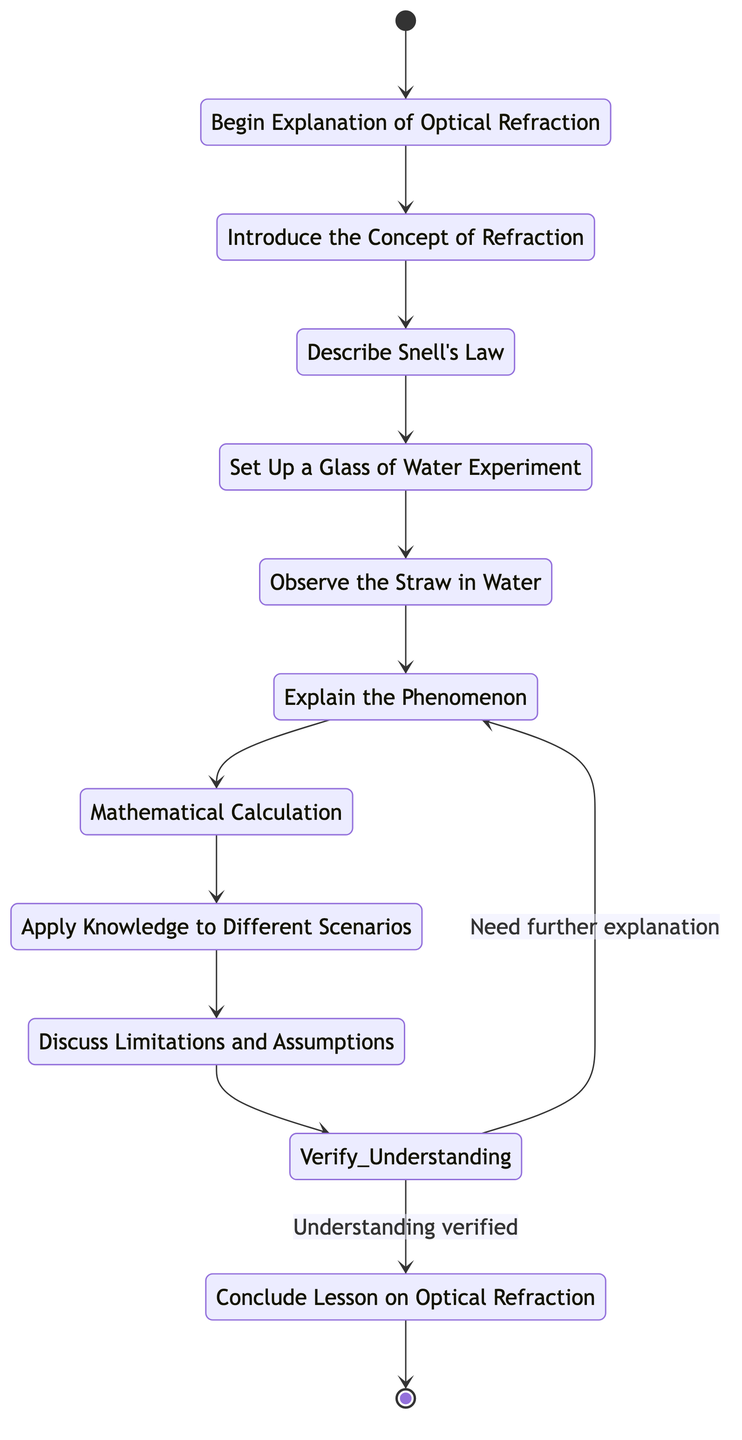What is the starting point of the activity diagram? The starting point is labeled as "Begin Explanation of Optical Refraction," indicating where the explanation process begins. This is the entry point from the initial state, leading to the first activity in the sequence.
Answer: Begin Explanation of Optical Refraction How many activities are listed in the diagram? There are eight activities outlined in the diagram, each of which describes a step in the explanation of optical refraction.
Answer: Eight What activity comes after "Describe Snell's Law"? The diagram shows that after "Describe Snell's Law," the next activity is "Set Up a Glass of Water Experiment." This indicates a direct flow from one task to the next in the instructional sequence.
Answer: Set Up a Glass of Water Experiment What is the decision point in this activity diagram? The decision point, indicated in the diagram, is "Verify Understanding." This represents a moment where the instructor determines whether the students grasp the concepts presented before proceeding.
Answer: Verify Understanding If the understanding is not verified, what happens next? If students do not understand the concepts, the flow goes back to "Explain the Phenomenon," indicating that further clarification and explanation are necessary to ensure comprehension before proceeding to the conclusion.
Answer: Explain the Phenomenon What is the final outcome of the diagram? The end event is labeled "Conclude Lesson on Optical Refraction," summarizing the key points discussed in the lesson and marking the conclusion of the activity flow.
Answer: Conclude Lesson on Optical Refraction Which activity emphasizes a real-world application of the concept? The activity that focuses on applying knowledge to real-world scenarios is "Apply Knowledge to Different Scenarios," encouraging students to think of other examples related to refraction.
Answer: Apply Knowledge to Different Scenarios What does the discussion of "Limitations and Assumptions" entail? The discussion of "Limitations and Assumptions" is an activity that elaborates on the constraints of the experiment and the assumptions made during the calculations regarding optical refraction, fostering critical thinking.
Answer: Discuss Limitations and Assumptions 